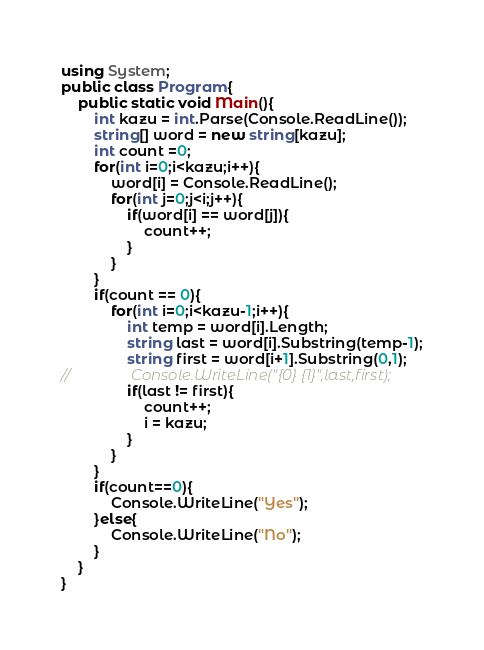Convert code to text. <code><loc_0><loc_0><loc_500><loc_500><_C#_>using System;
public class Program{
    public static void Main(){
        int kazu = int.Parse(Console.ReadLine());
        string[] word = new string[kazu];
        int count =0;
        for(int i=0;i<kazu;i++){
            word[i] = Console.ReadLine();
            for(int j=0;j<i;j++){
                if(word[i] == word[j]){
                    count++;
                }
            }
        }
        if(count == 0){
            for(int i=0;i<kazu-1;i++){
                int temp = word[i].Length;
                string last = word[i].Substring(temp-1);
                string first = word[i+1].Substring(0,1);
//                Console.WriteLine("{0} {1}",last,first);
                if(last != first){
                    count++;
                    i = kazu;
                }
            }
        }
        if(count==0){
            Console.WriteLine("Yes");
        }else{
            Console.WriteLine("No");
        }
    }
}</code> 